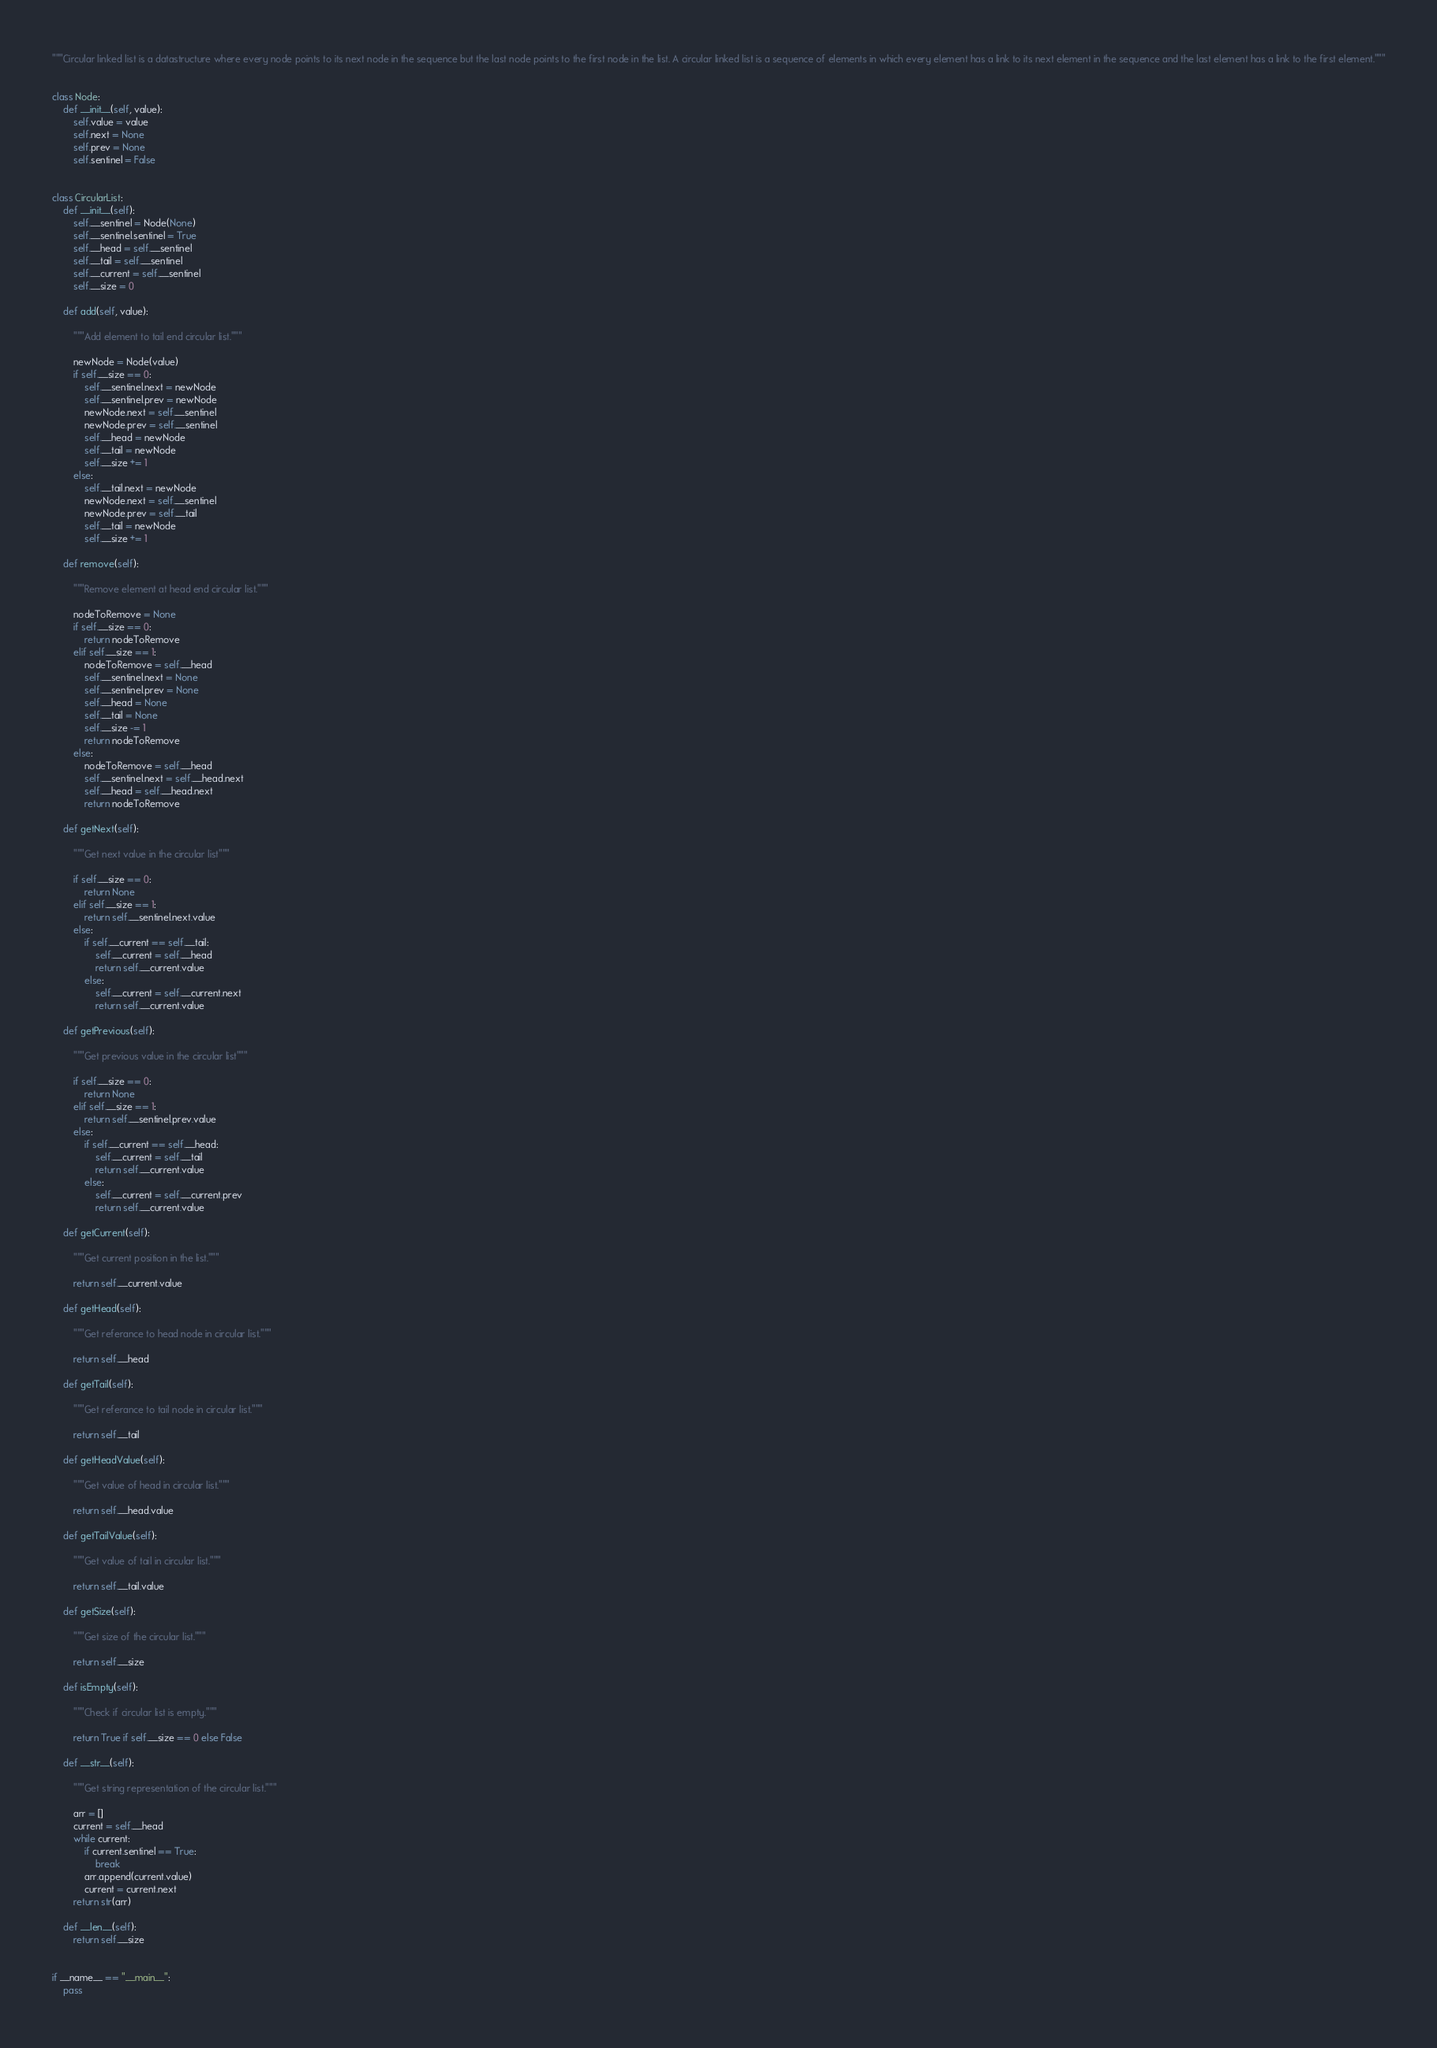<code> <loc_0><loc_0><loc_500><loc_500><_Python_>"""Circular linked list is a datastructure where every node points to its next node in the sequence but the last node points to the first node in the list. A circular linked list is a sequence of elements in which every element has a link to its next element in the sequence and the last element has a link to the first element."""


class Node:
    def __init__(self, value):
        self.value = value
        self.next = None
        self.prev = None
        self.sentinel = False


class CircularList:
    def __init__(self):
        self.__sentinel = Node(None)
        self.__sentinel.sentinel = True
        self.__head = self.__sentinel
        self.__tail = self.__sentinel
        self.__current = self.__sentinel
        self.__size = 0

    def add(self, value):

        """Add element to tail end circular list."""

        newNode = Node(value)
        if self.__size == 0:
            self.__sentinel.next = newNode
            self.__sentinel.prev = newNode
            newNode.next = self.__sentinel
            newNode.prev = self.__sentinel
            self.__head = newNode
            self.__tail = newNode
            self.__size += 1
        else:
            self.__tail.next = newNode
            newNode.next = self.__sentinel
            newNode.prev = self.__tail
            self.__tail = newNode
            self.__size += 1

    def remove(self):

        """Remove element at head end circular list."""

        nodeToRemove = None
        if self.__size == 0:
            return nodeToRemove
        elif self.__size == 1:
            nodeToRemove = self.__head
            self.__sentinel.next = None
            self.__sentinel.prev = None
            self.__head = None
            self.__tail = None
            self.__size -= 1
            return nodeToRemove
        else:
            nodeToRemove = self.__head
            self.__sentinel.next = self.__head.next
            self.__head = self.__head.next
            return nodeToRemove

    def getNext(self):

        """Get next value in the circular list"""

        if self.__size == 0:
            return None
        elif self.__size == 1:
            return self.__sentinel.next.value
        else:
            if self.__current == self.__tail:
                self.__current = self.__head
                return self.__current.value
            else:
                self.__current = self.__current.next
                return self.__current.value

    def getPrevious(self):

        """Get previous value in the circular list"""

        if self.__size == 0:
            return None
        elif self.__size == 1:
            return self.__sentinel.prev.value
        else:
            if self.__current == self.__head:
                self.__current = self.__tail
                return self.__current.value
            else:
                self.__current = self.__current.prev
                return self.__current.value

    def getCurrent(self):

        """Get current position in the list."""

        return self.__current.value

    def getHead(self):

        """Get referance to head node in circular list."""

        return self.__head

    def getTail(self):

        """Get referance to tail node in circular list."""

        return self.__tail

    def getHeadValue(self):

        """Get value of head in circular list."""

        return self.__head.value

    def getTailValue(self):

        """Get value of tail in circular list."""

        return self.__tail.value

    def getSize(self):

        """Get size of the circular list."""

        return self.__size

    def isEmpty(self):

        """Check if circular list is empty."""

        return True if self.__size == 0 else False

    def __str__(self):

        """Get string representation of the circular list."""

        arr = []
        current = self.__head
        while current:
            if current.sentinel == True:
                break
            arr.append(current.value)
            current = current.next
        return str(arr)

    def __len__(self):
        return self.__size


if __name__ == "__main__":
    pass
</code> 